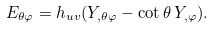<formula> <loc_0><loc_0><loc_500><loc_500>E _ { \theta \varphi } = h _ { u v } ( Y _ { , \theta \varphi } - \cot \theta \, Y _ { , \varphi } ) .</formula> 